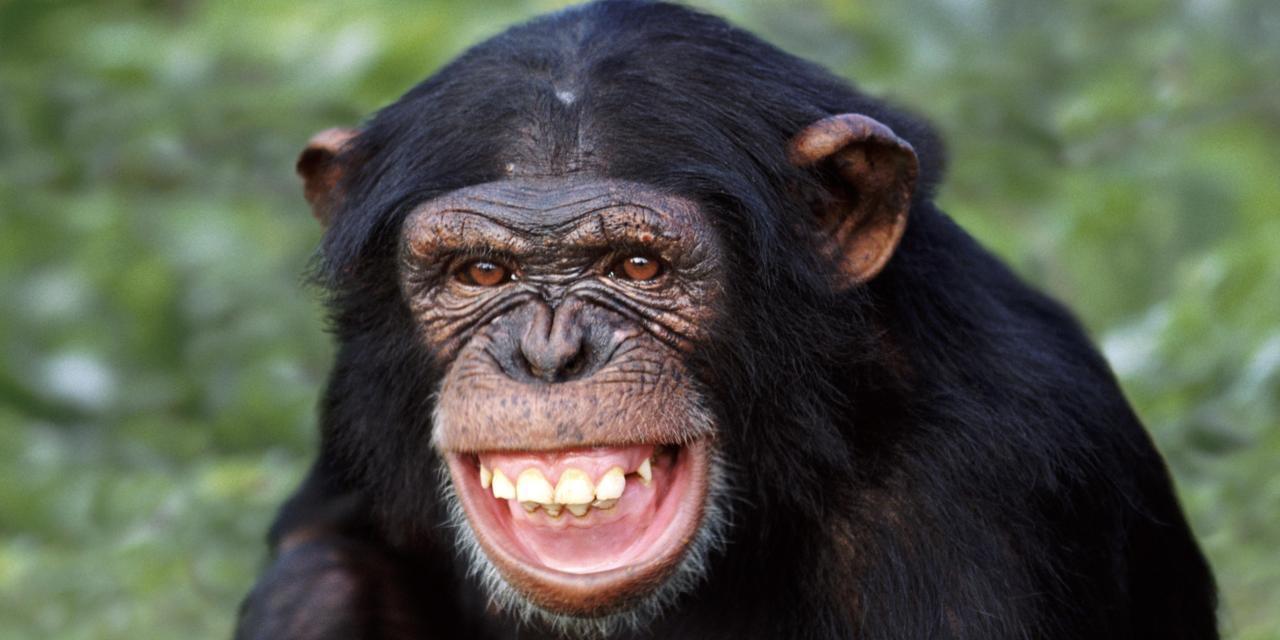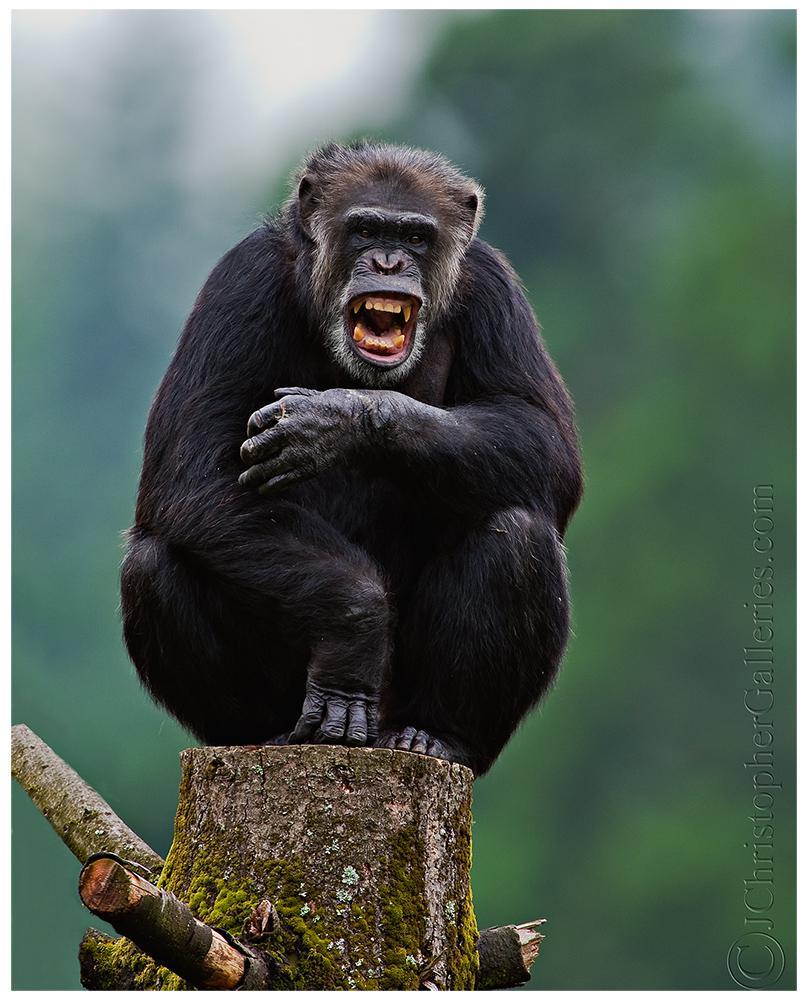The first image is the image on the left, the second image is the image on the right. Considering the images on both sides, is "In the left image, one chimp is baring its teeth." valid? Answer yes or no. Yes. The first image is the image on the left, the second image is the image on the right. Given the left and right images, does the statement "There are two apes" hold true? Answer yes or no. Yes. 